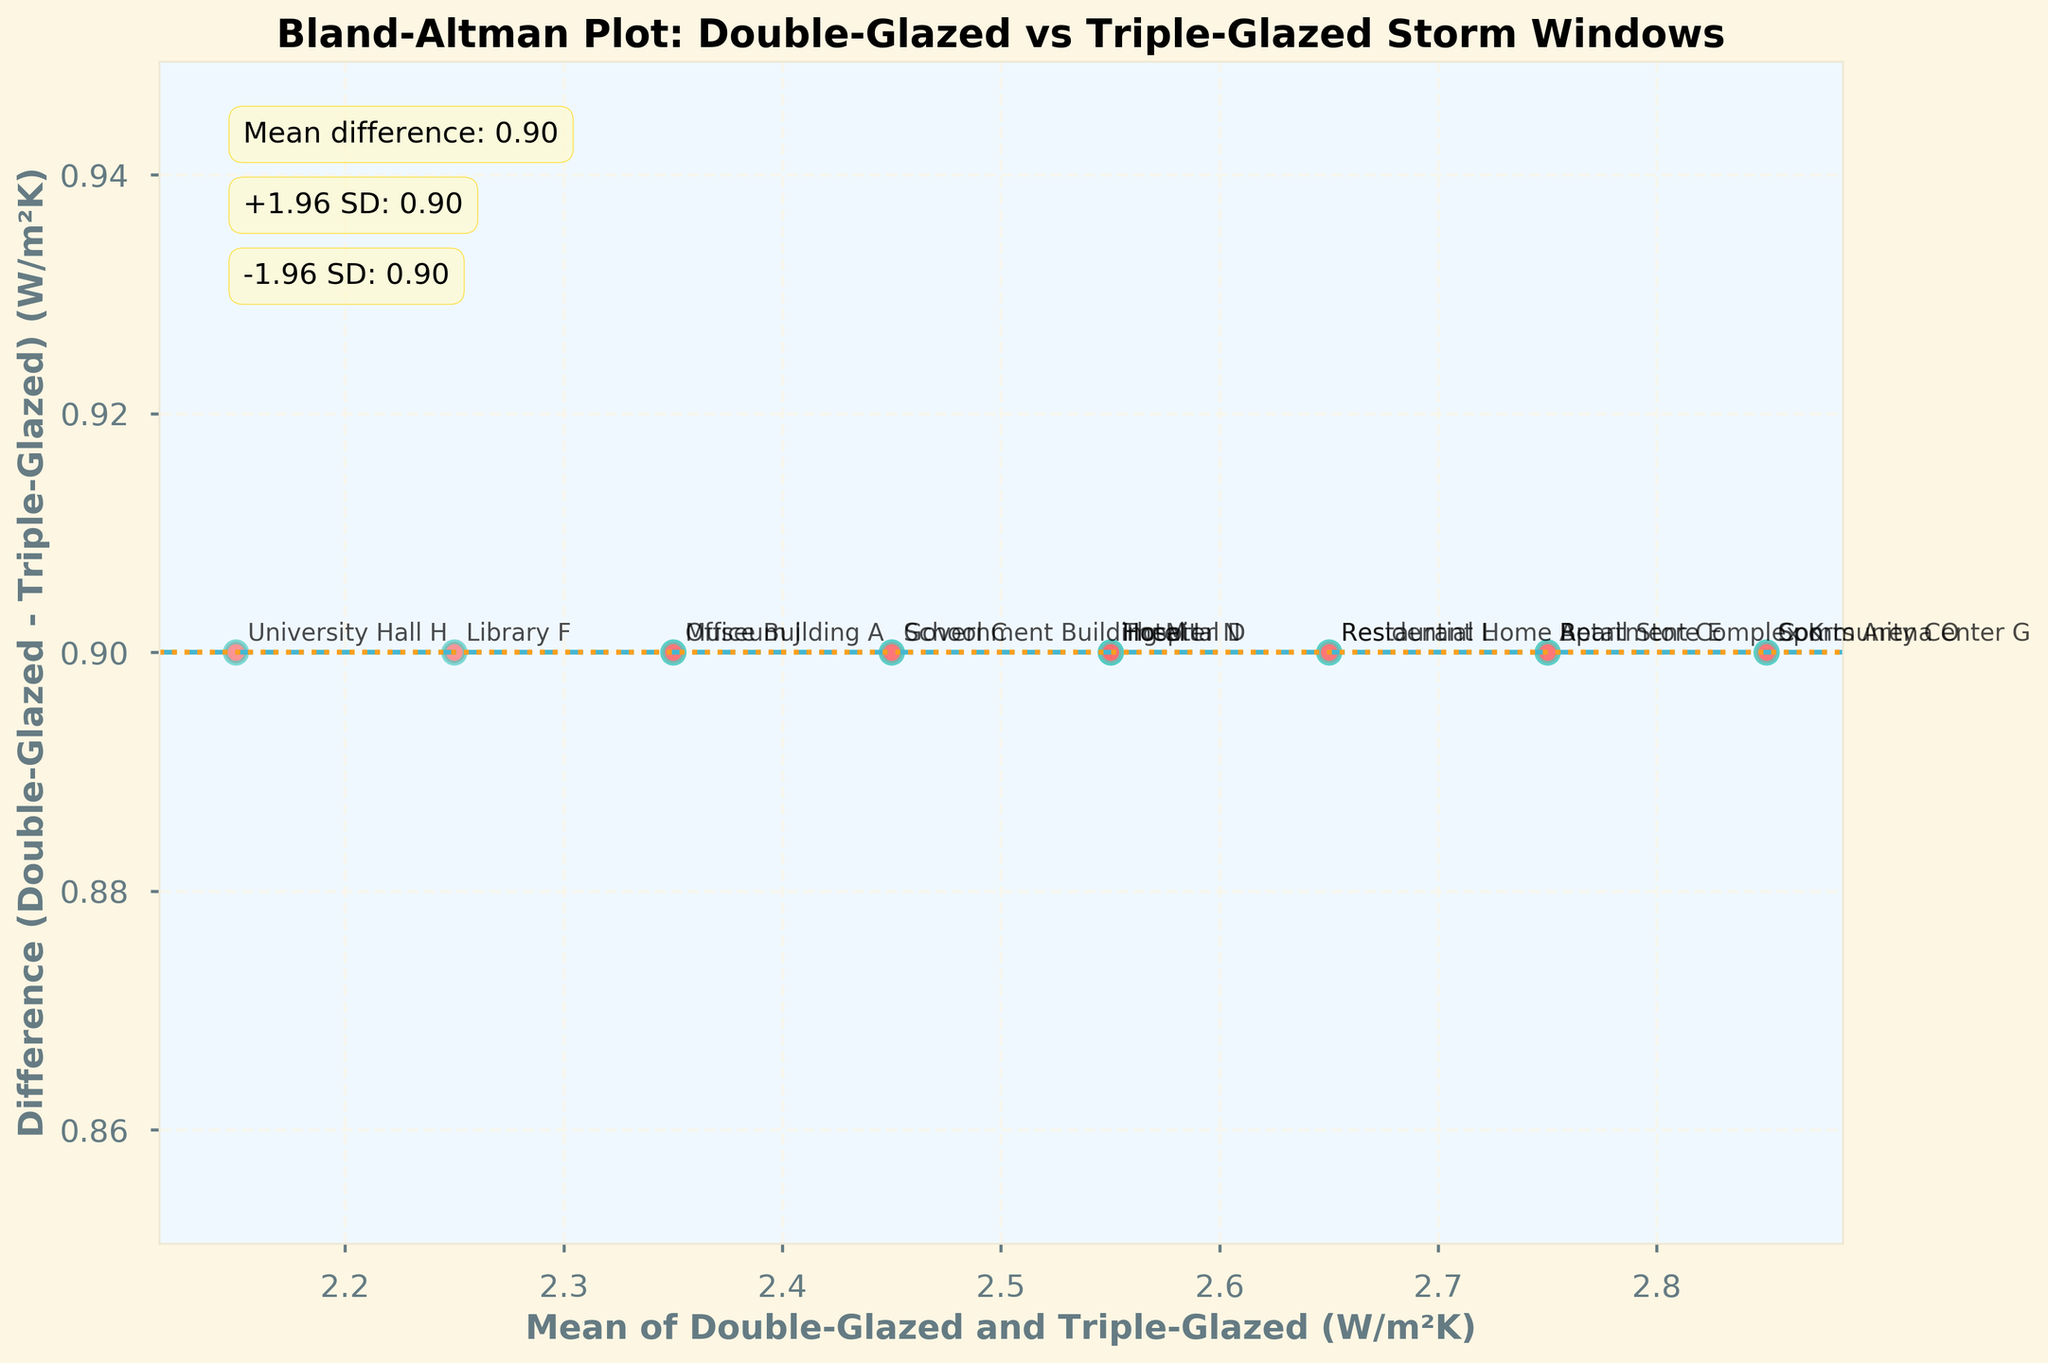what is the title of the plot? The title is located at the top of the figure and provides a summary of the data being visualized. Here, the title reads "Bland-Altman Plot: Double-Glazed vs Triple-Glazed Storm Windows"
Answer: Bland-Altman Plot: Double-Glazed vs Triple-Glazed Storm Windows How many data points are plotted in the figure? The number of data points corresponds to the number of buildings analyzed for their double-glazed and triple-glazed storm windows. By counting the scatter points, we determine there are 15 points.
Answer: 15 What does the x-axis represent? The x-axis represents the mean thermal insulation performance of double-glazed and triple-glazed storm windows measured in W/m²K, as indicated by the axis label.
Answer: Mean of Double-Glazed and Triple-Glazed (W/m²K) What color is used for the scatter points? The scatter points are colored in a unique style to differentiate them, and here they appear in a reddish-pink shade with green edges, as visually noted.
Answer: reddish-pink What are the limits of agreement based on the 1.96 standard deviations rule? The limits of agreement are shown as dashed and dotted horizontal lines on the plot. According to the plot annotations, these values are outlined as +1.96 SD and -1.96 SD values.
Answer: +1.30 and -0.10 What is the mean difference between double-glazed and triple-glazed thermal insulation performance? The mean difference is shown as a horizontal dashed line and is also annotated on the plot. By referring to the text, it's -0.70.
Answer: -0.70 Which building type exhibits the highest mean value for thermal insulation performance? To find the highest mean value, look at the x-axis values of the scatter points. The annotation "Community Center G" is associated with the highest x-axis value, indicating it has the highest mean.
Answer: Community Center G For which building type is the difference between double-glazed and triple-glazed the largest? To find the largest difference, examine the scatter points for the y-axis values. The building "Community Center G" has the largest positive y-value, which means it has the largest difference.
Answer: Community Center G Which building types have the same mean thermal insulation performance value? To determine identical mean values, look for points that align vertically on the x-axis. "Hospital D" and "Hotel I" both align at a mean value of approximately 2.55.
Answer: Hospital D and Hotel I Is the difference between double-glazed and triple-glazed performance consistent across building types? By examining the distribution of points around the mean difference line, we see variability in the y-values, indicating inconsistency in the differences across building types.
Answer: No 